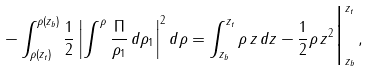Convert formula to latex. <formula><loc_0><loc_0><loc_500><loc_500>- \int _ { \rho ( z _ { t } ) } ^ { \rho ( z _ { b } ) } \frac { 1 } { 2 } \left | \int ^ { \rho } \frac { \Pi } { \rho _ { 1 } } \, d \rho _ { 1 } \right | ^ { 2 } d \rho = \int _ { z _ { b } } ^ { z _ { t } } \rho \, z \, d z - \frac { 1 } { 2 } \rho \, z ^ { 2 } \Big | _ { z _ { b } } ^ { z _ { t } } \, ,</formula> 